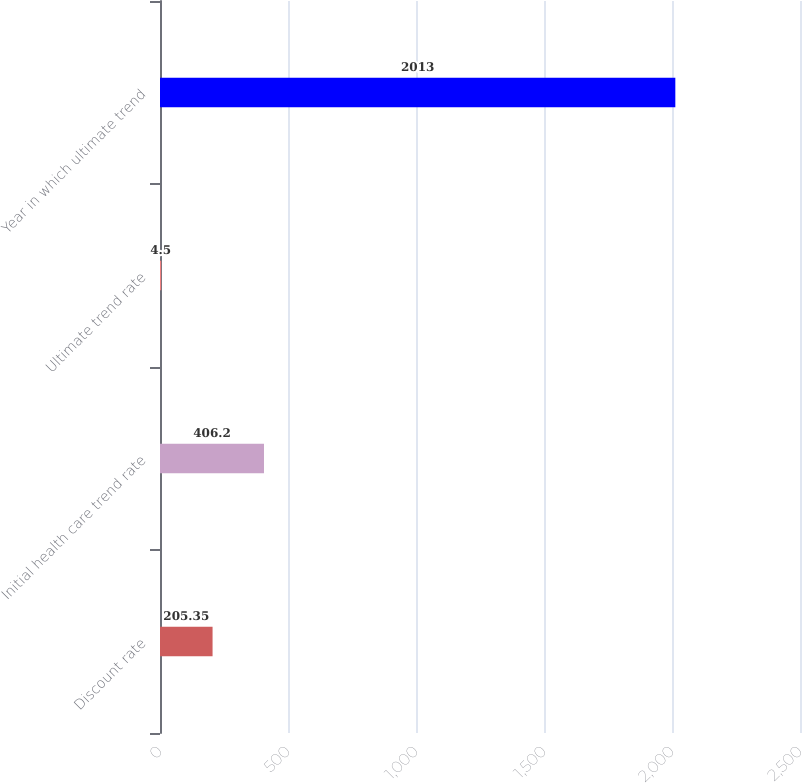<chart> <loc_0><loc_0><loc_500><loc_500><bar_chart><fcel>Discount rate<fcel>Initial health care trend rate<fcel>Ultimate trend rate<fcel>Year in which ultimate trend<nl><fcel>205.35<fcel>406.2<fcel>4.5<fcel>2013<nl></chart> 